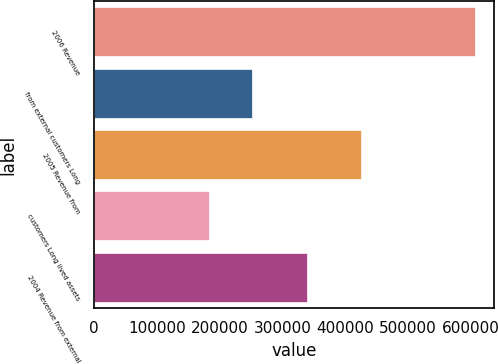Convert chart. <chart><loc_0><loc_0><loc_500><loc_500><bar_chart><fcel>2006 Revenue<fcel>from external customers Long<fcel>2005 Revenue from<fcel>customers Long lived assets<fcel>2004 Revenue from external<nl><fcel>606996<fcel>252426<fcel>425505<fcel>183459<fcel>339338<nl></chart> 